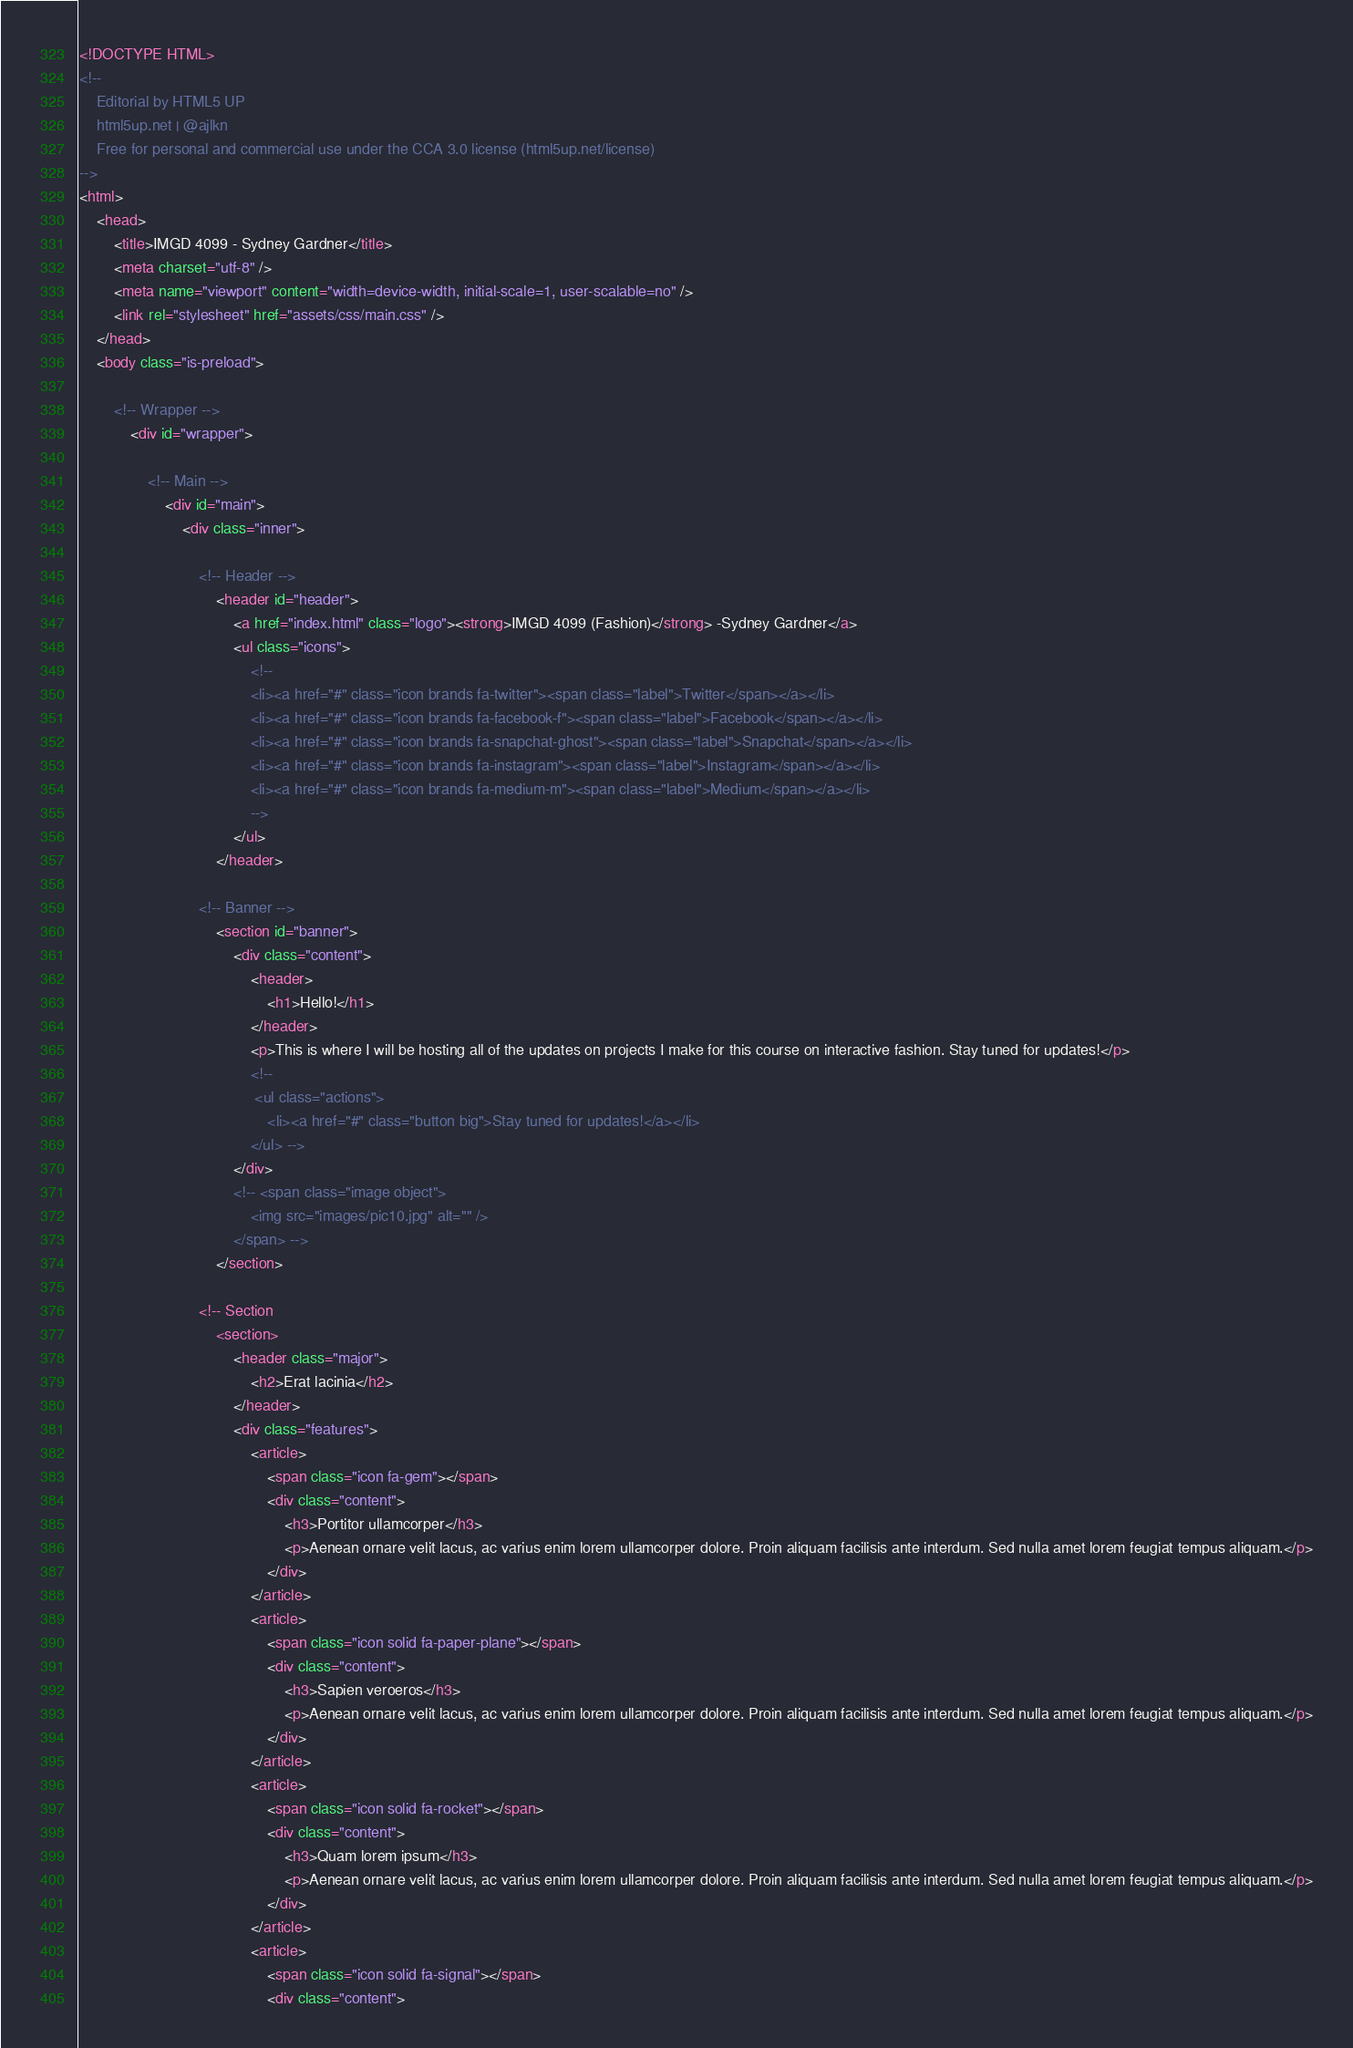Convert code to text. <code><loc_0><loc_0><loc_500><loc_500><_HTML_><!DOCTYPE HTML>
<!--
	Editorial by HTML5 UP
	html5up.net | @ajlkn
	Free for personal and commercial use under the CCA 3.0 license (html5up.net/license)
-->
<html>
	<head>
		<title>IMGD 4099 - Sydney Gardner</title>
		<meta charset="utf-8" />
		<meta name="viewport" content="width=device-width, initial-scale=1, user-scalable=no" />
		<link rel="stylesheet" href="assets/css/main.css" />
	</head>
	<body class="is-preload">

		<!-- Wrapper -->
			<div id="wrapper">

				<!-- Main -->
					<div id="main">
						<div class="inner">

							<!-- Header -->
								<header id="header">
									<a href="index.html" class="logo"><strong>IMGD 4099 (Fashion)</strong> -Sydney Gardner</a>
									<ul class="icons">
										<!--
										<li><a href="#" class="icon brands fa-twitter"><span class="label">Twitter</span></a></li>
										<li><a href="#" class="icon brands fa-facebook-f"><span class="label">Facebook</span></a></li>
										<li><a href="#" class="icon brands fa-snapchat-ghost"><span class="label">Snapchat</span></a></li>
										<li><a href="#" class="icon brands fa-instagram"><span class="label">Instagram</span></a></li>
										<li><a href="#" class="icon brands fa-medium-m"><span class="label">Medium</span></a></li>
										-->
									</ul>
								</header>

							<!-- Banner -->
								<section id="banner">
									<div class="content">
										<header>
											<h1>Hello!</h1>
										</header>
										<p>This is where I will be hosting all of the updates on projects I make for this course on interactive fashion. Stay tuned for updates!</p>
										<!--
										 <ul class="actions">
											<li><a href="#" class="button big">Stay tuned for updates!</a></li>
										</ul> -->
									</div>
									<!-- <span class="image object">
										<img src="images/pic10.jpg" alt="" />
									</span> -->
								</section>

							<!-- Section
								<section>
									<header class="major">
										<h2>Erat lacinia</h2>
									</header>
									<div class="features">
										<article>
											<span class="icon fa-gem"></span>
											<div class="content">
												<h3>Portitor ullamcorper</h3>
												<p>Aenean ornare velit lacus, ac varius enim lorem ullamcorper dolore. Proin aliquam facilisis ante interdum. Sed nulla amet lorem feugiat tempus aliquam.</p>
											</div>
										</article>
										<article>
											<span class="icon solid fa-paper-plane"></span>
											<div class="content">
												<h3>Sapien veroeros</h3>
												<p>Aenean ornare velit lacus, ac varius enim lorem ullamcorper dolore. Proin aliquam facilisis ante interdum. Sed nulla amet lorem feugiat tempus aliquam.</p>
											</div>
										</article>
										<article>
											<span class="icon solid fa-rocket"></span>
											<div class="content">
												<h3>Quam lorem ipsum</h3>
												<p>Aenean ornare velit lacus, ac varius enim lorem ullamcorper dolore. Proin aliquam facilisis ante interdum. Sed nulla amet lorem feugiat tempus aliquam.</p>
											</div>
										</article>
										<article>
											<span class="icon solid fa-signal"></span>
											<div class="content"></code> 